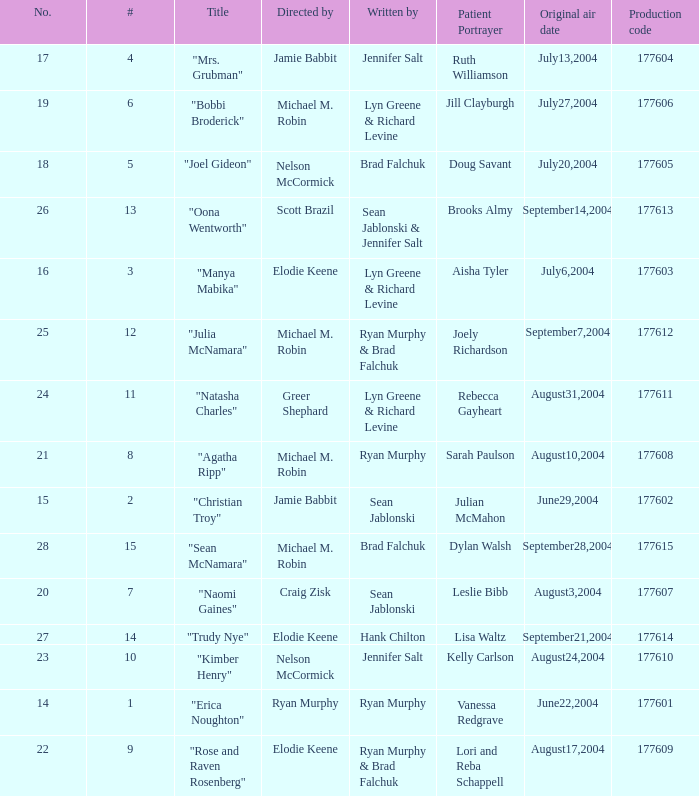Who directed the episode with production code 177605? Nelson McCormick. 